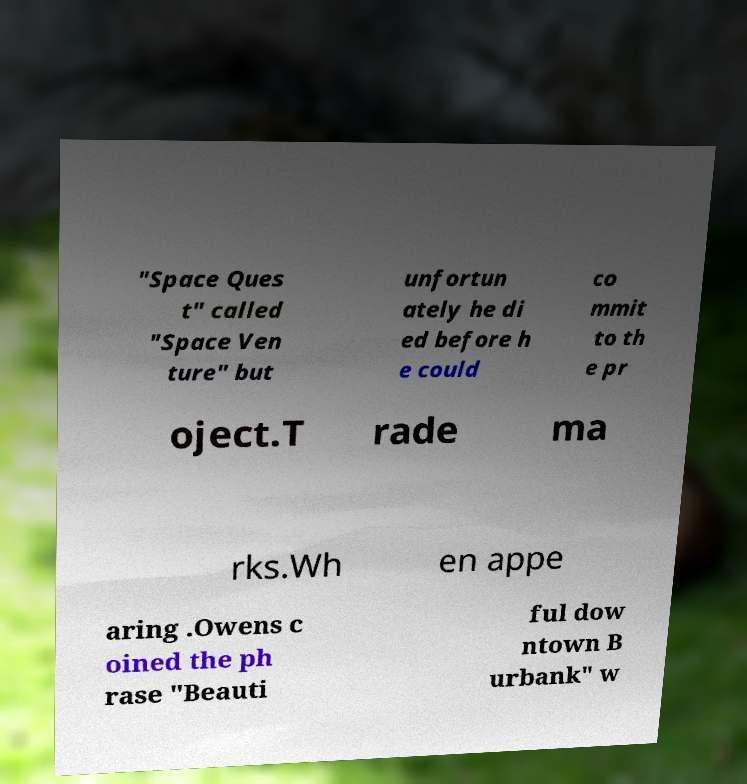There's text embedded in this image that I need extracted. Can you transcribe it verbatim? "Space Ques t" called "Space Ven ture" but unfortun ately he di ed before h e could co mmit to th e pr oject.T rade ma rks.Wh en appe aring .Owens c oined the ph rase "Beauti ful dow ntown B urbank" w 